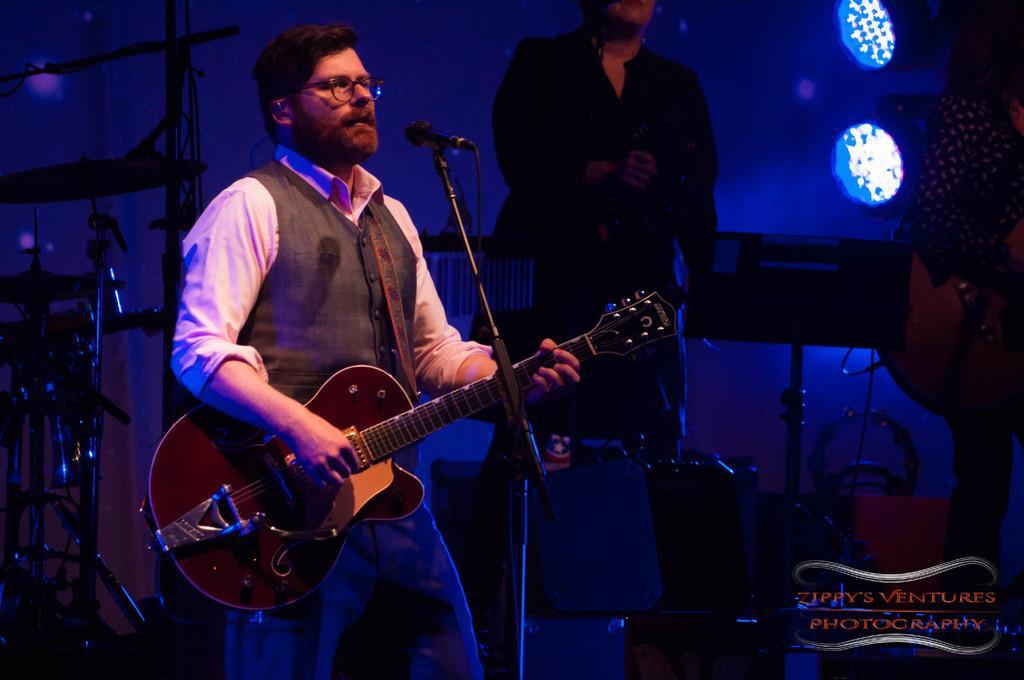How would you summarize this image in a sentence or two? In this image in the front there is a man standing and holding a guitar in his hand and in front of the man there is a mic and a stand. In the background there are musical instruments and there are persons standing and there are lights. 